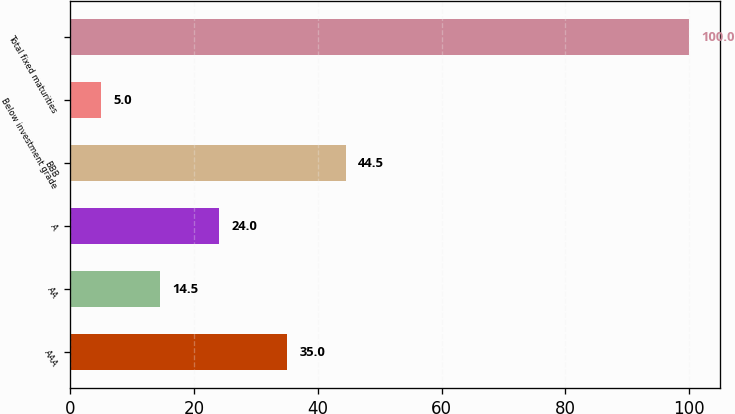Convert chart. <chart><loc_0><loc_0><loc_500><loc_500><bar_chart><fcel>AAA<fcel>AA<fcel>A<fcel>BBB<fcel>Below investment grade<fcel>Total fixed maturities<nl><fcel>35<fcel>14.5<fcel>24<fcel>44.5<fcel>5<fcel>100<nl></chart> 